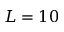Convert formula to latex. <formula><loc_0><loc_0><loc_500><loc_500>L = 1 0</formula> 